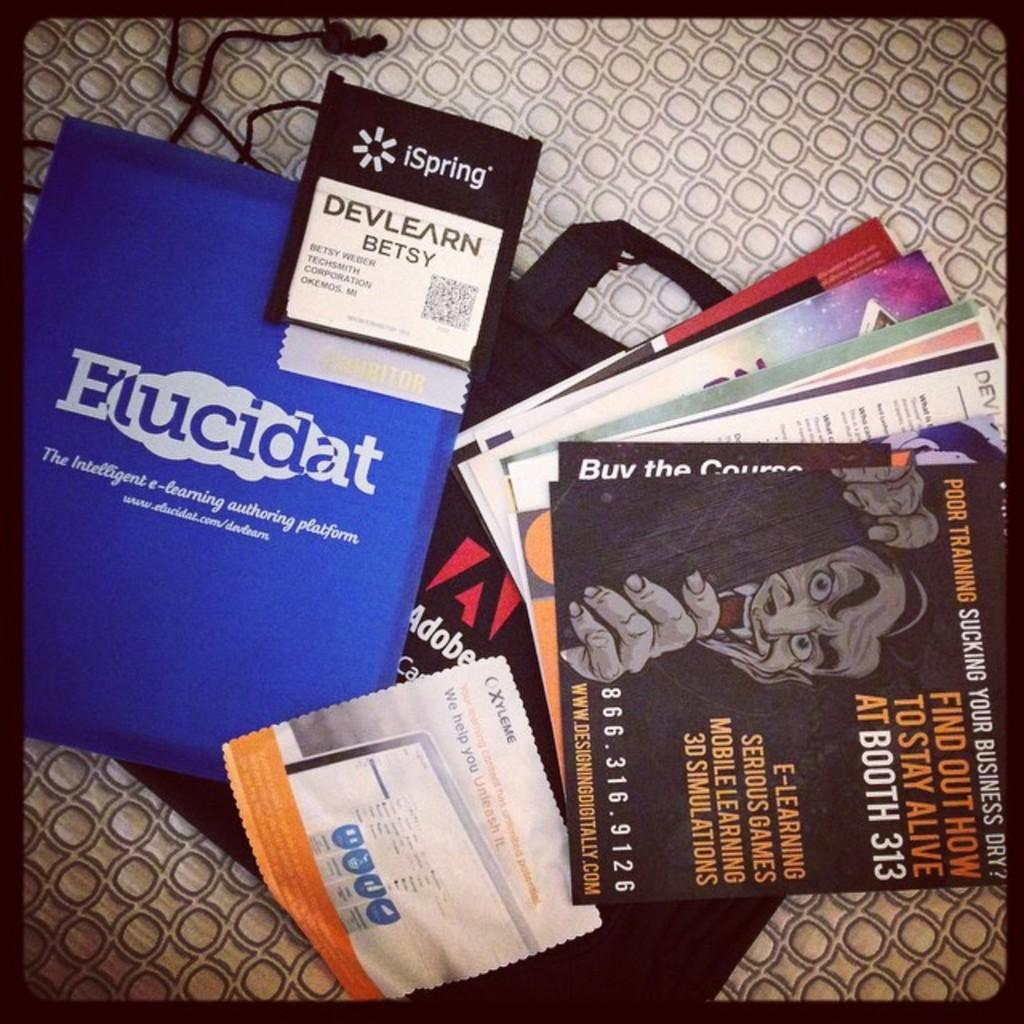<image>
Relay a brief, clear account of the picture shown. A few flyers for e-learning sit on top of carpet. 